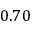<formula> <loc_0><loc_0><loc_500><loc_500>0 . 7 0</formula> 